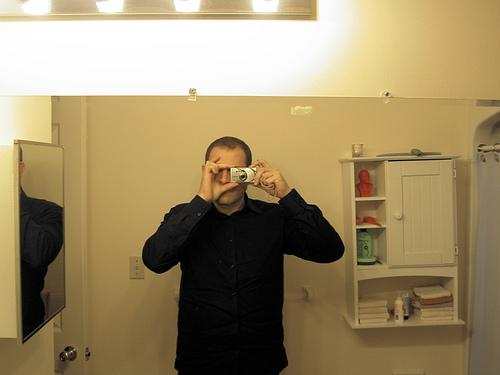What type of camera is he using? Please explain your reasoning. digital. A small silver camera with a small lens is being aimed by a man in a bathroom. 